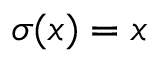Convert formula to latex. <formula><loc_0><loc_0><loc_500><loc_500>\sigma ( x ) = x</formula> 